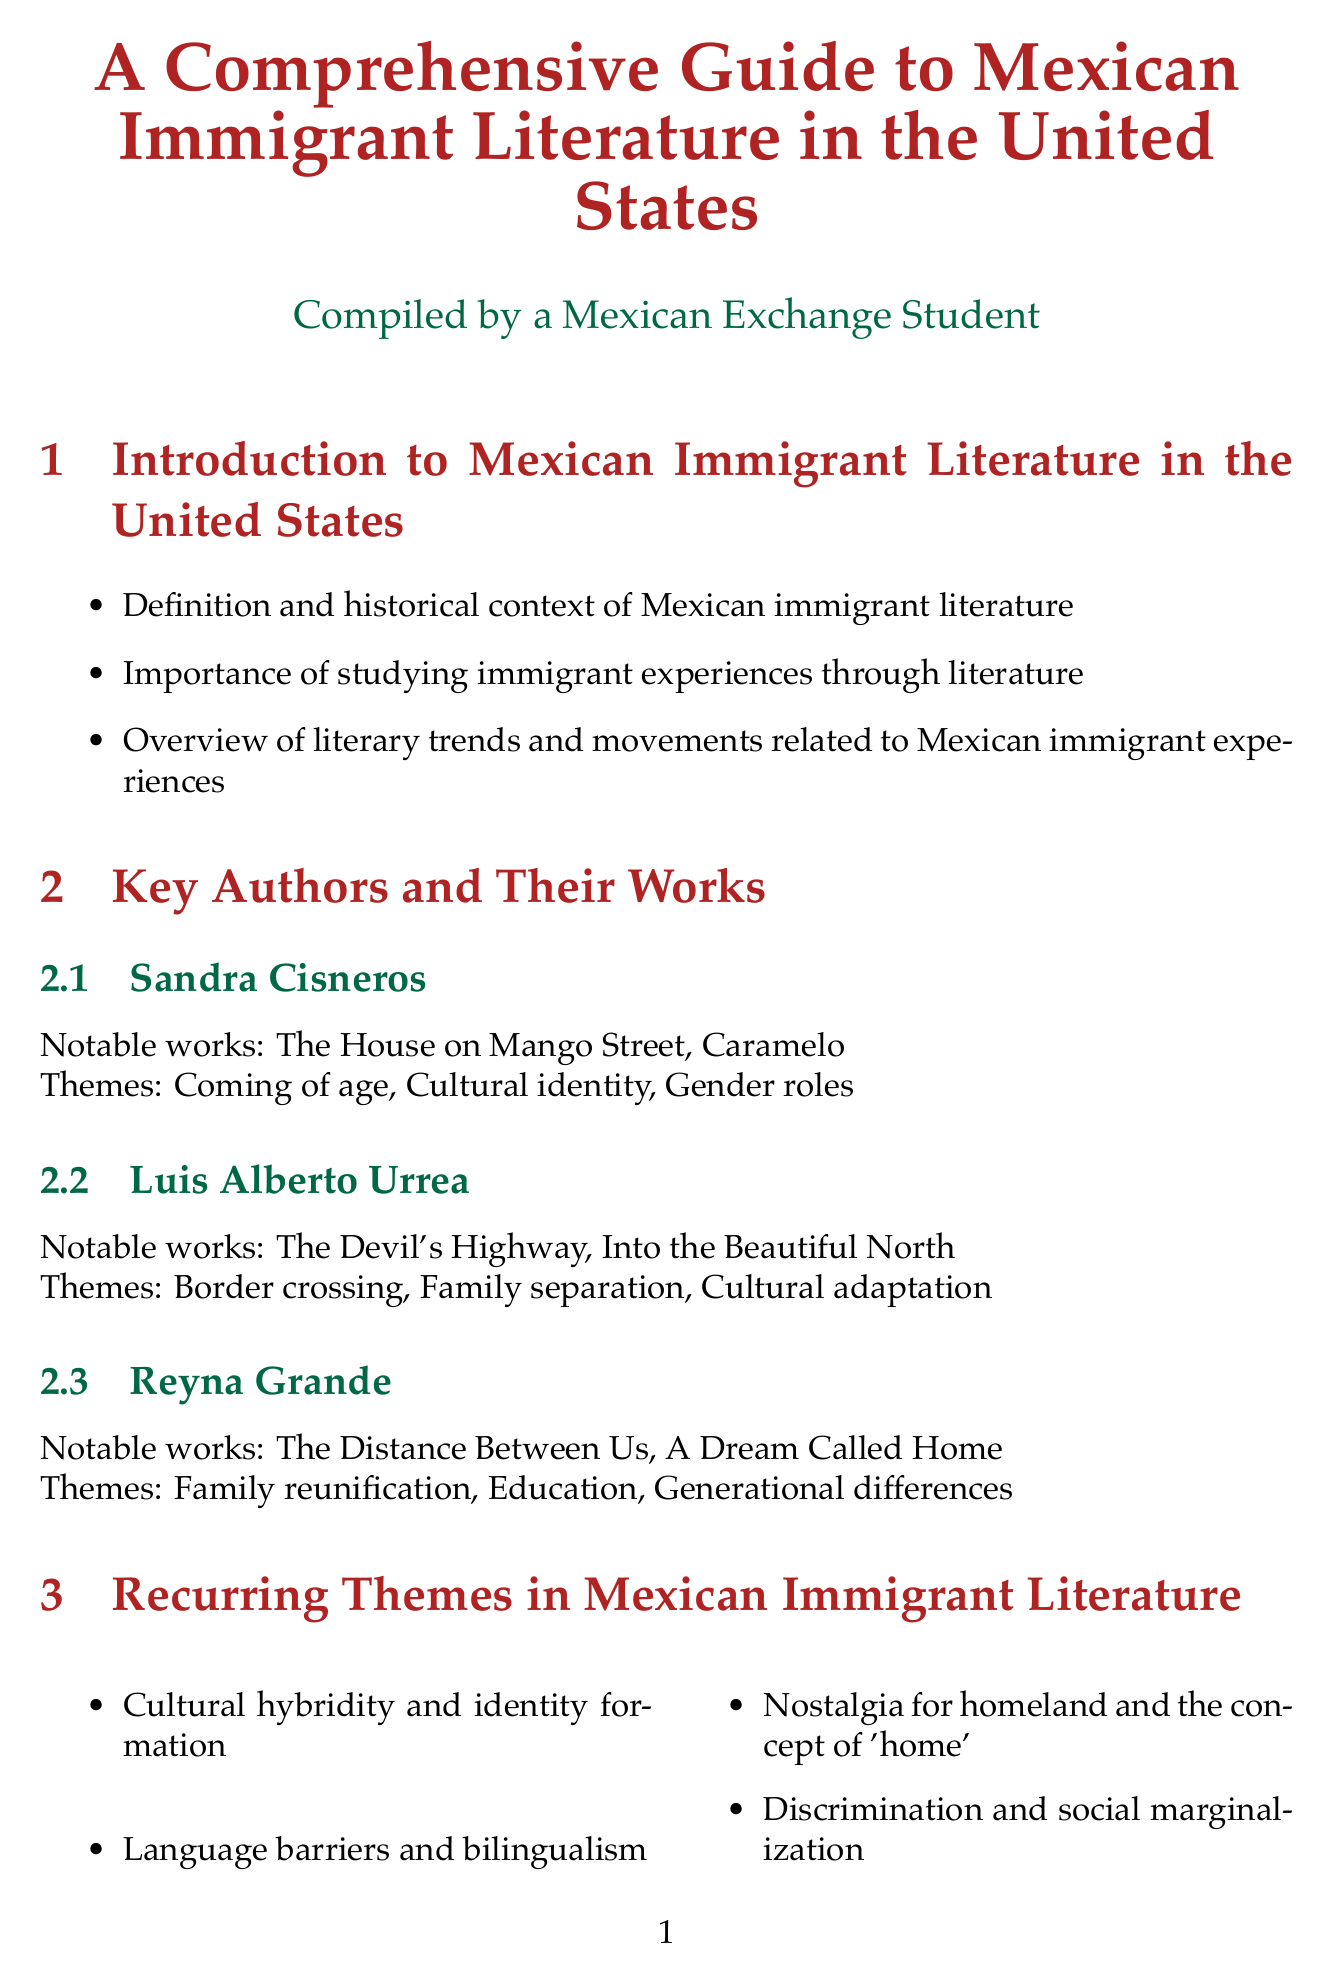What is the definition of Mexican immigrant literature? The document states that it includes the definition and historical context of Mexican immigrant literature.
Answer: Definition and historical context Who is the author of "The House on Mango Street"? This information is found under the Key Authors and Their Works section, referring to Sandra Cisneros.
Answer: Sandra Cisneros What is a recurring theme in Mexican immigrant literature? The document lists several themes, one of which is cultural hybridity and identity formation.
Answer: Cultural hybridity and identity formation What literary technique conveys cultural experiences through magical elements? The document mentions the use of magical realism to convey cultural experiences.
Answer: Magical realism What is the name of the journal mentioned for further study? Key academic journals are listed, one of which is Latino Studies.
Answer: Latino Studies Which topic is addressed under Critical Approaches to Analyzing Mexican Immigrant Literature? The document covers various critical approaches, including postcolonial theory and border studies.
Answer: Postcolonial theory Name one notable work by Valeria Luiselli. The document provides notable works under contemporary trends, including Lost Children Archive.
Answer: Lost Children Archive What theme is associated with Reyna Grande's works? The document states that one of the themes is family reunification.
Answer: Family reunification 